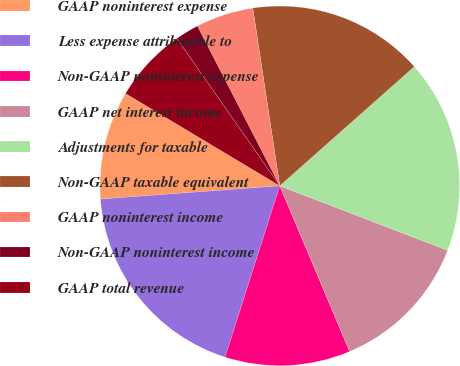<chart> <loc_0><loc_0><loc_500><loc_500><pie_chart><fcel>GAAP noninterest expense<fcel>Less expense attributable to<fcel>Non-GAAP noninterest expense<fcel>GAAP net interest income<fcel>Adjustments for taxable<fcel>Non-GAAP taxable equivalent<fcel>GAAP noninterest income<fcel>Non-GAAP noninterest income<fcel>GAAP total revenue<nl><fcel>9.76%<fcel>18.91%<fcel>11.28%<fcel>12.81%<fcel>17.38%<fcel>15.86%<fcel>5.18%<fcel>2.13%<fcel>6.71%<nl></chart> 